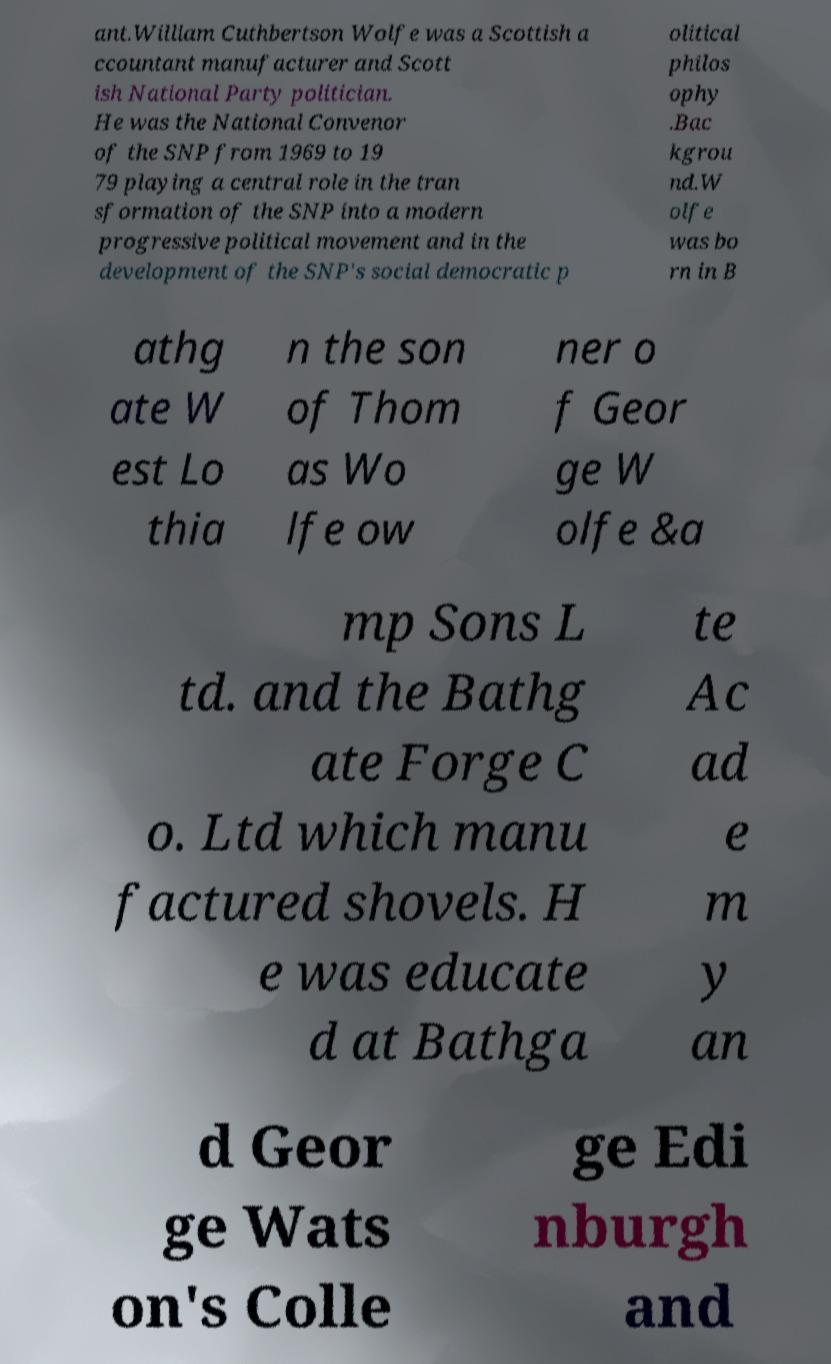Could you assist in decoding the text presented in this image and type it out clearly? ant.William Cuthbertson Wolfe was a Scottish a ccountant manufacturer and Scott ish National Party politician. He was the National Convenor of the SNP from 1969 to 19 79 playing a central role in the tran sformation of the SNP into a modern progressive political movement and in the development of the SNP's social democratic p olitical philos ophy .Bac kgrou nd.W olfe was bo rn in B athg ate W est Lo thia n the son of Thom as Wo lfe ow ner o f Geor ge W olfe &a mp Sons L td. and the Bathg ate Forge C o. Ltd which manu factured shovels. H e was educate d at Bathga te Ac ad e m y an d Geor ge Wats on's Colle ge Edi nburgh and 